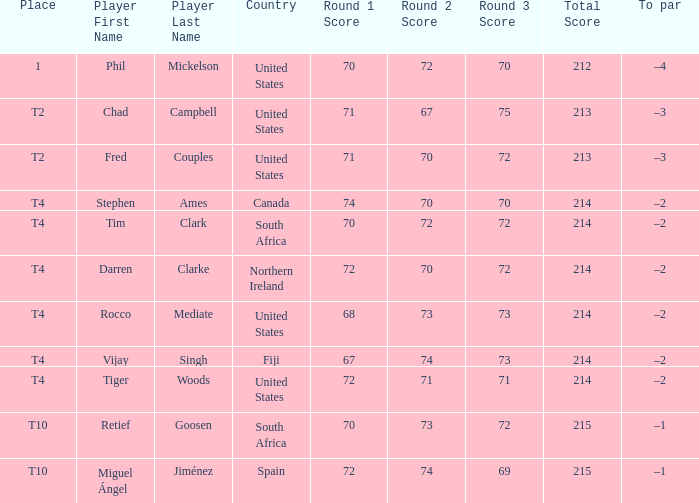How many points did spain achieve? 72-74-69=215. 